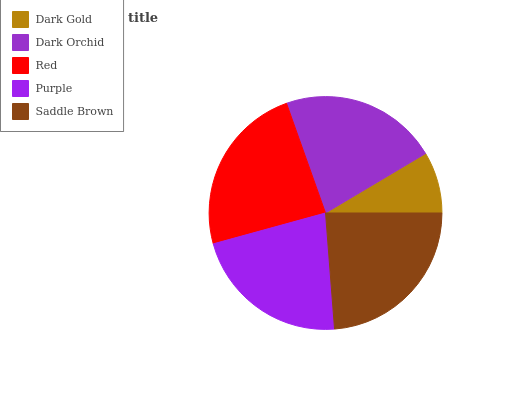Is Dark Gold the minimum?
Answer yes or no. Yes. Is Red the maximum?
Answer yes or no. Yes. Is Dark Orchid the minimum?
Answer yes or no. No. Is Dark Orchid the maximum?
Answer yes or no. No. Is Dark Orchid greater than Dark Gold?
Answer yes or no. Yes. Is Dark Gold less than Dark Orchid?
Answer yes or no. Yes. Is Dark Gold greater than Dark Orchid?
Answer yes or no. No. Is Dark Orchid less than Dark Gold?
Answer yes or no. No. Is Purple the high median?
Answer yes or no. Yes. Is Purple the low median?
Answer yes or no. Yes. Is Dark Gold the high median?
Answer yes or no. No. Is Dark Gold the low median?
Answer yes or no. No. 